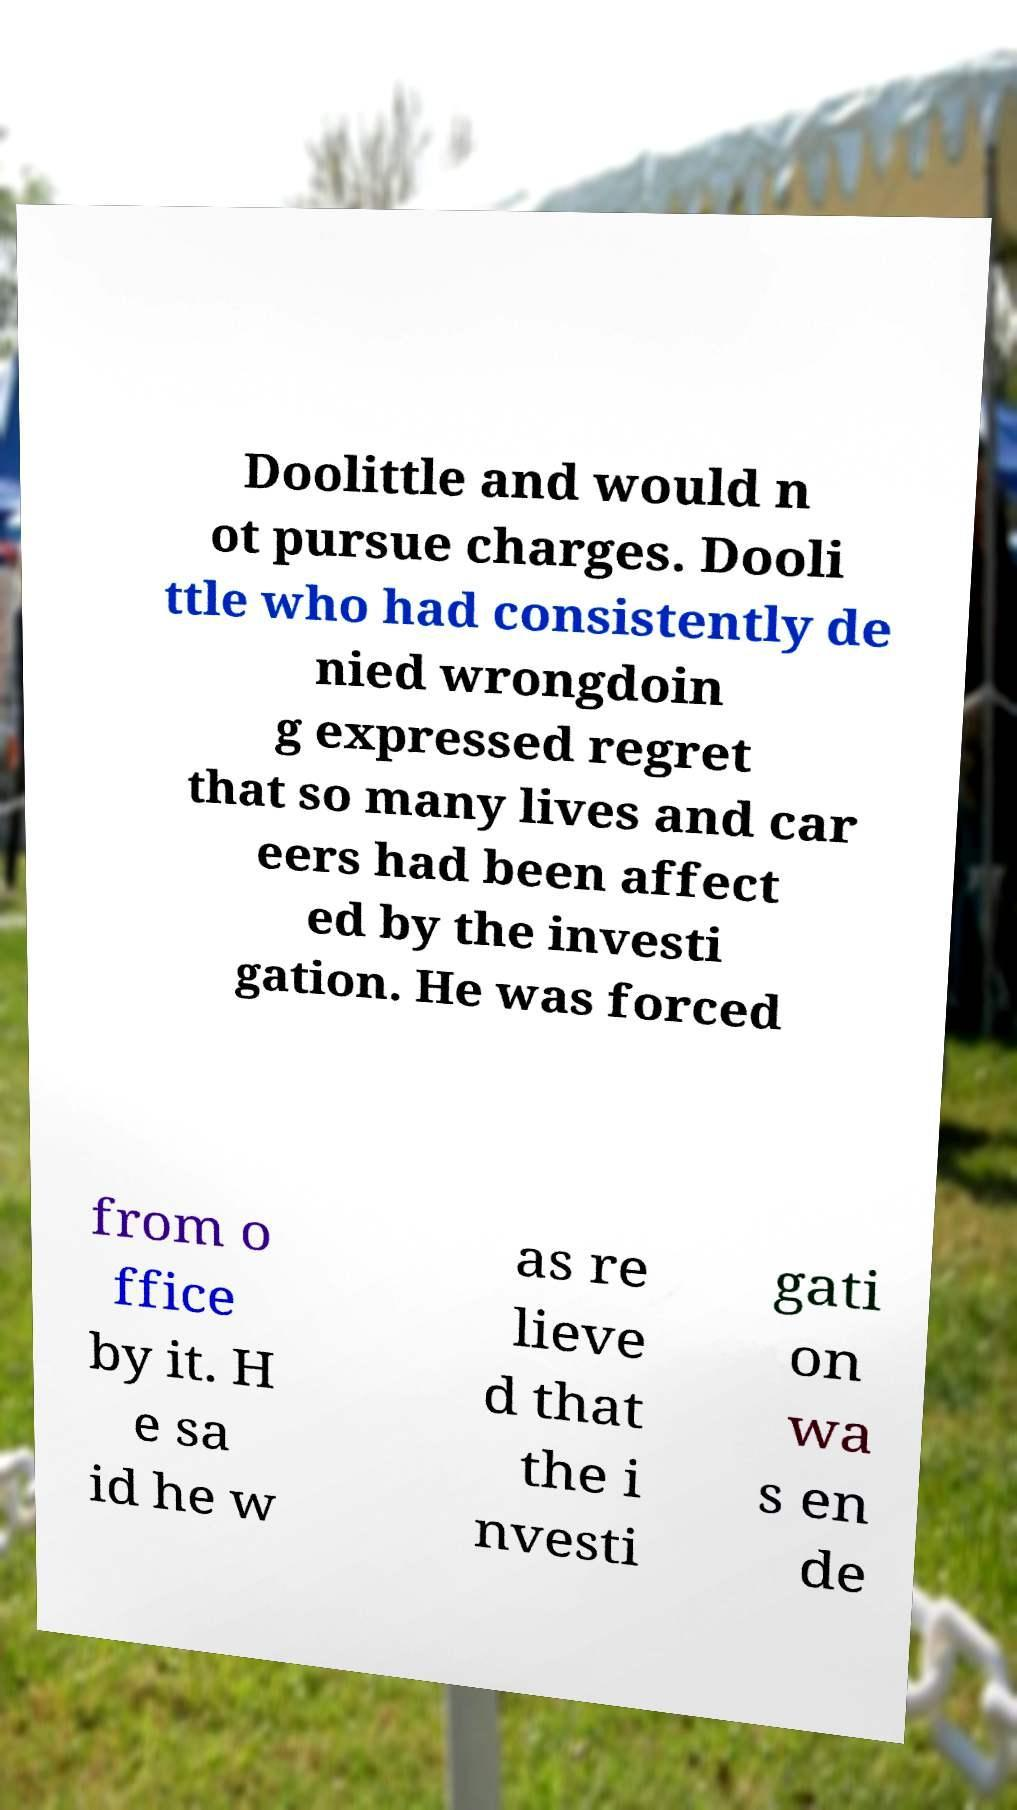Could you assist in decoding the text presented in this image and type it out clearly? Doolittle and would n ot pursue charges. Dooli ttle who had consistently de nied wrongdoin g expressed regret that so many lives and car eers had been affect ed by the investi gation. He was forced from o ffice by it. H e sa id he w as re lieve d that the i nvesti gati on wa s en de 